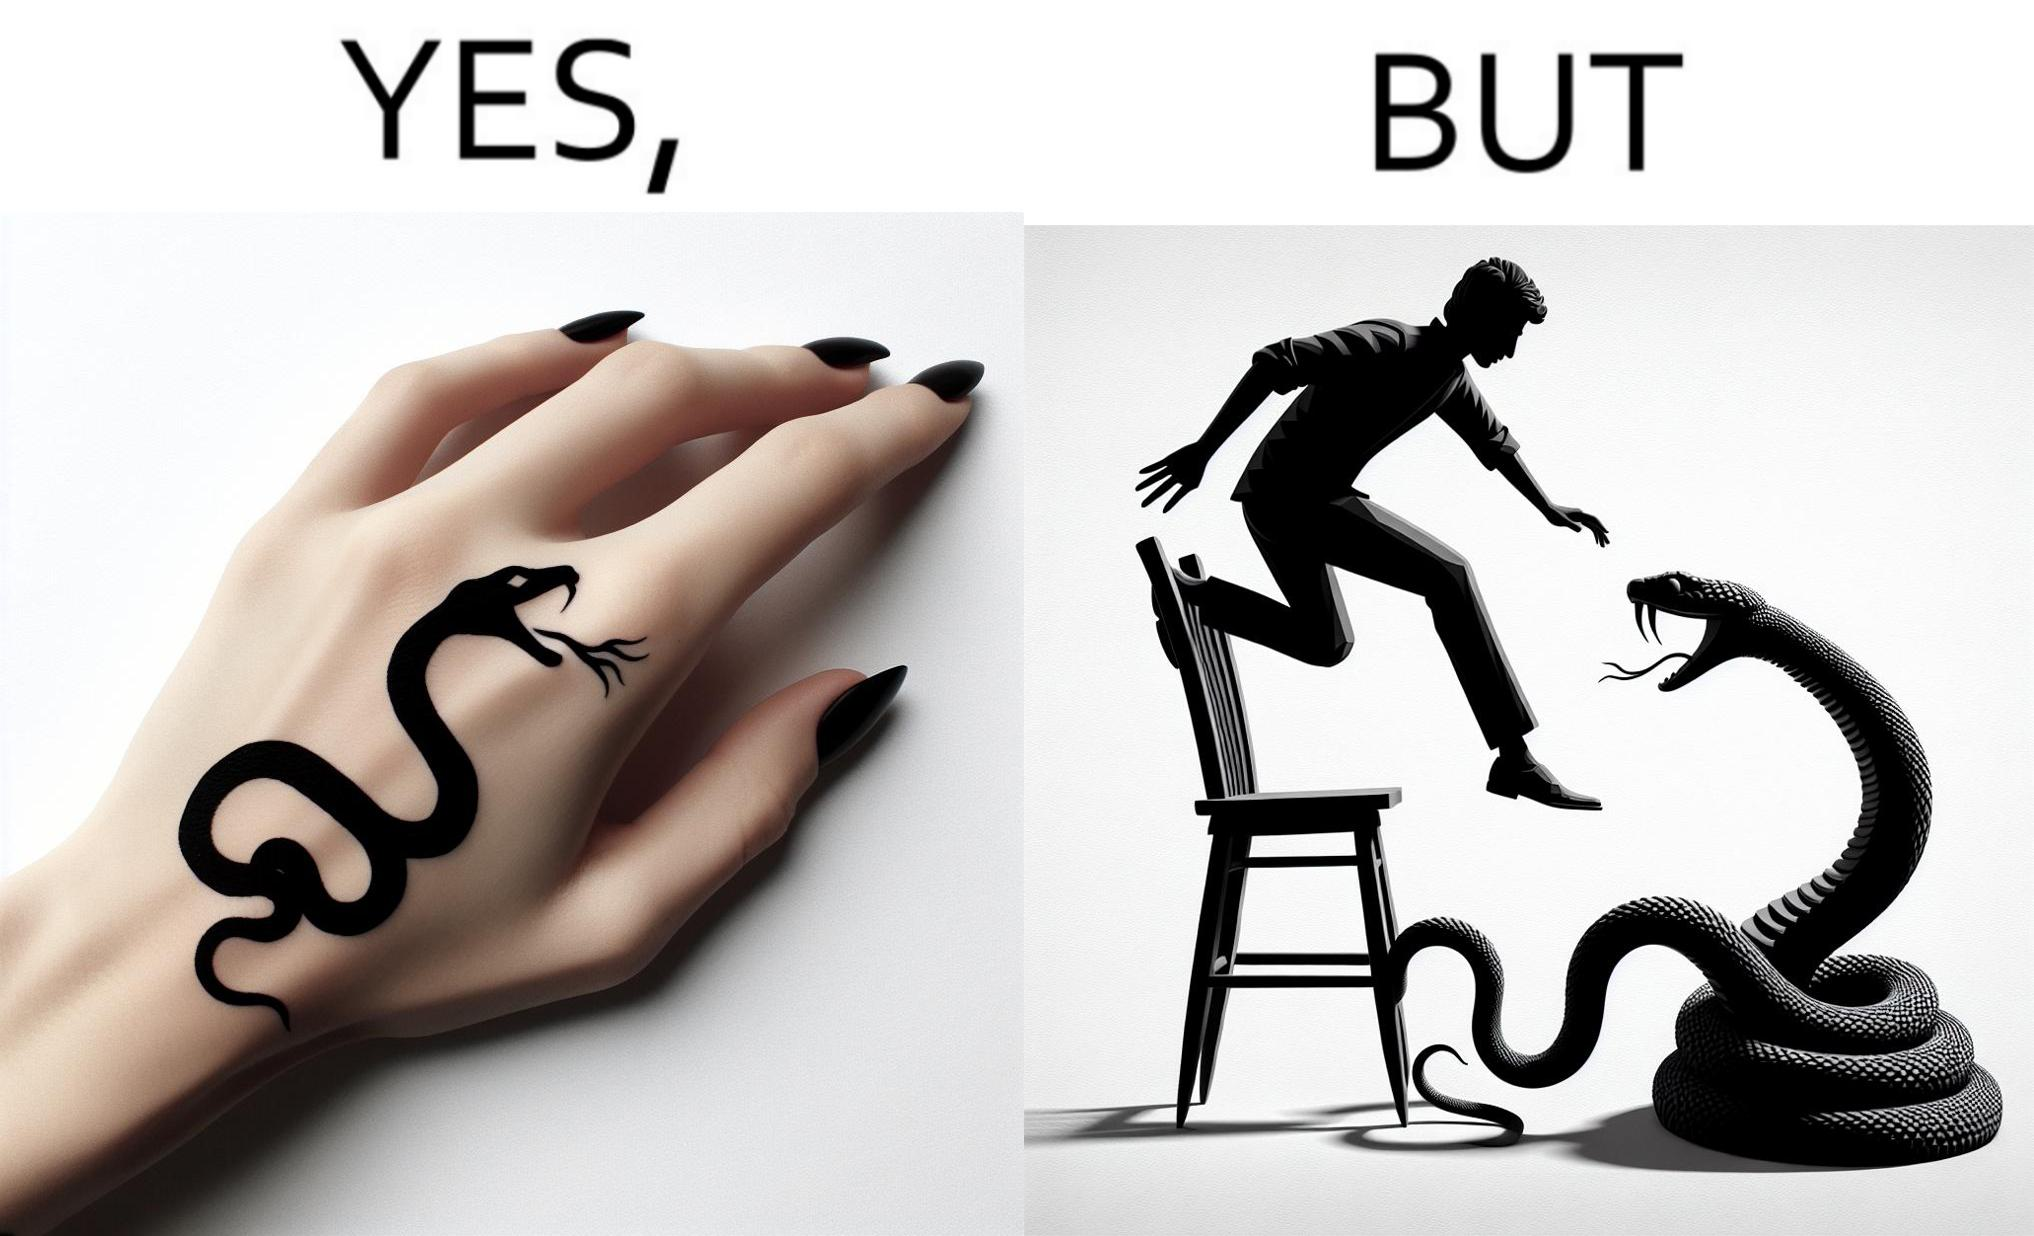What is the satirical meaning behind this image? The image is ironic, because in the first image the tattoo of a snake on someone's hand may give us a hint about how powerful or brave the person can be who is having this tattoo but in the second image the person with same tattoo is seen frightened due to a snake in his house 